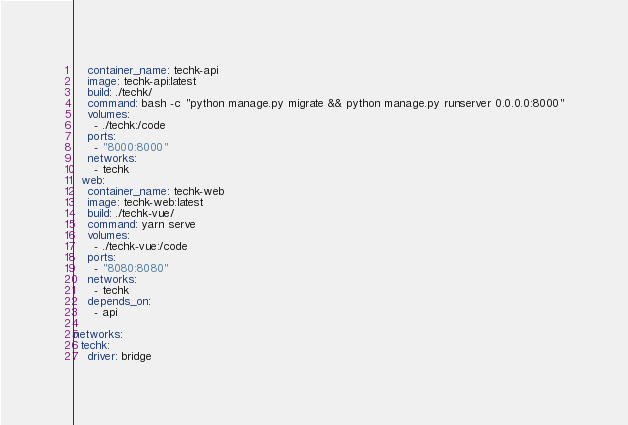Convert code to text. <code><loc_0><loc_0><loc_500><loc_500><_YAML_>    container_name: techk-api
    image: techk-api:latest
    build: ./techk/
    command: bash -c "python manage.py migrate && python manage.py runserver 0.0.0.0:8000"
    volumes:
      - ./techk:/code
    ports:
      - "8000:8000"
    networks:
      - techk
  web:
    container_name: techk-web
    image: techk-web:latest
    build: ./techk-vue/
    command: yarn serve
    volumes:
      - ./techk-vue:/code
    ports:
      - "8080:8080"
    networks:
      - techk
    depends_on:
      - api

networks:
  techk:
    driver: bridge
</code> 